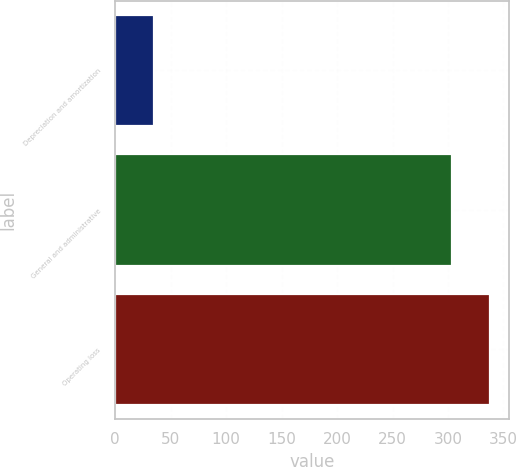Convert chart. <chart><loc_0><loc_0><loc_500><loc_500><bar_chart><fcel>Depreciation and amortization<fcel>General and administrative<fcel>Operating loss<nl><fcel>34.7<fcel>303.2<fcel>337.9<nl></chart> 